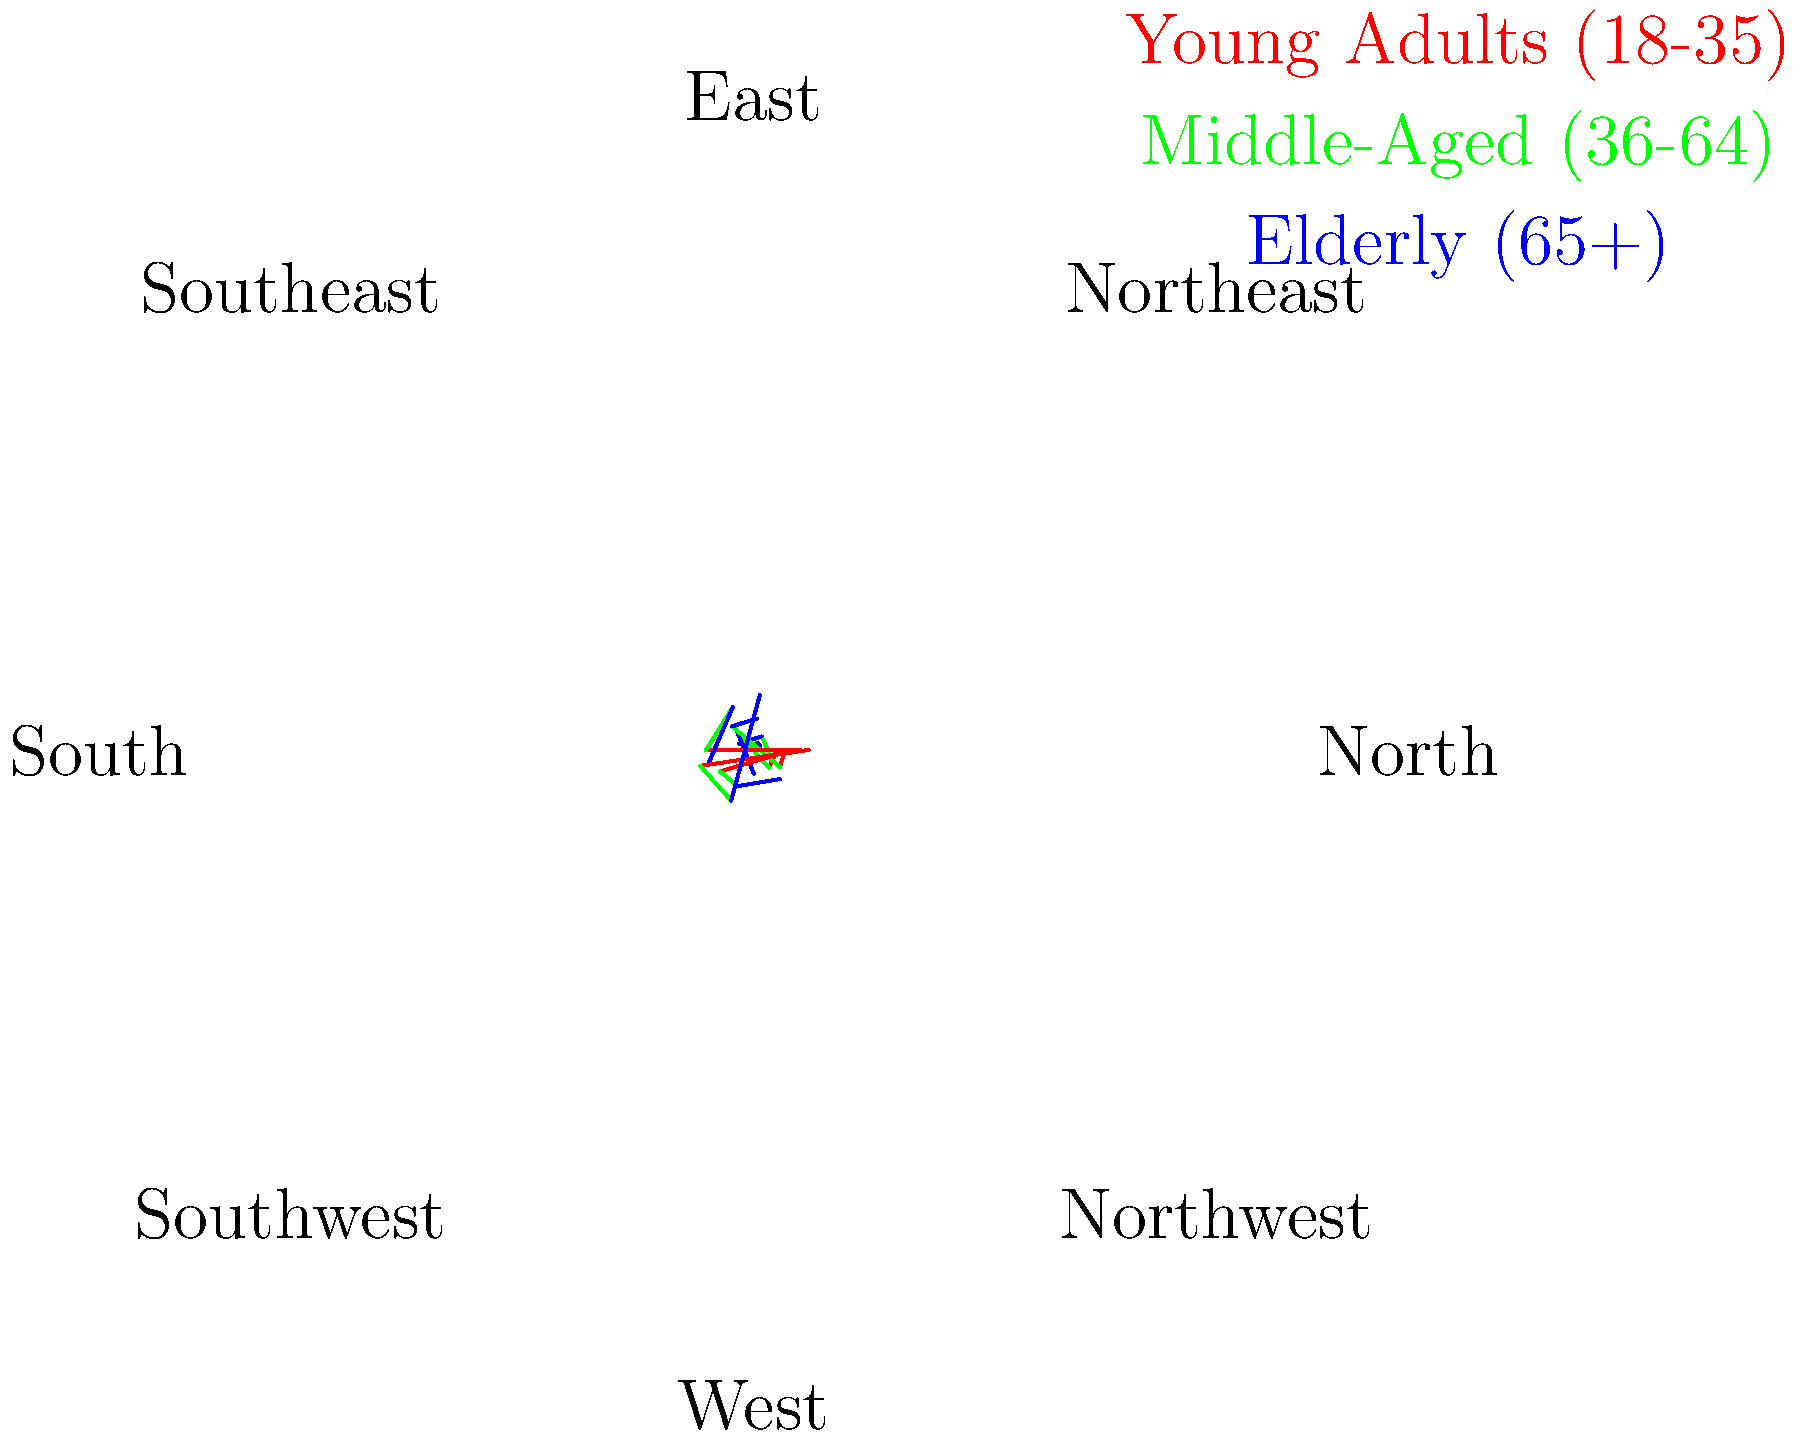Based on the polar stacked bar chart showing demographic shifts in different sectors of the city, which sector has the highest percentage of elderly residents (blue segment) relative to its total population? To determine which sector has the highest percentage of elderly residents, we need to follow these steps:

1. Identify the blue segment (elderly population) in each sector.
2. Compare the blue segment to the total height of each bar (total population).
3. Calculate the percentage of elderly for each sector.
4. Identify the sector with the highest percentage.

Let's analyze each sector:

North: Elderly ≈ 10 out of 55 total (18.2%)
Northeast: Elderly ≈ 12 out of 57 total (21.1%)
East: Elderly ≈ 8 out of 53 total (15.1%)
Southeast: Elderly ≈ 15 out of 55 total (27.3%)
South: Elderly ≈ 18 out of 58 total (31.0%)
Southwest: Elderly ≈ 20 out of 62 total (32.3%)
West: Elderly ≈ 14 out of 60 total (23.3%)
Northwest: Elderly ≈ 16 out of 58 total (27.6%)

The Southwest sector has the highest percentage of elderly residents at approximately 32.3% of its total population.
Answer: Southwest 